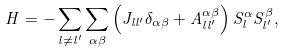<formula> <loc_0><loc_0><loc_500><loc_500>H = - \sum _ { l \ne l ^ { \prime } } \sum _ { \alpha \beta } \left ( J _ { l l ^ { \prime } } \delta _ { \alpha \beta } + A ^ { \alpha \beta } _ { l l ^ { \prime } } \right ) S _ { l } ^ { \alpha } S _ { l ^ { \prime } } ^ { \beta } ,</formula> 